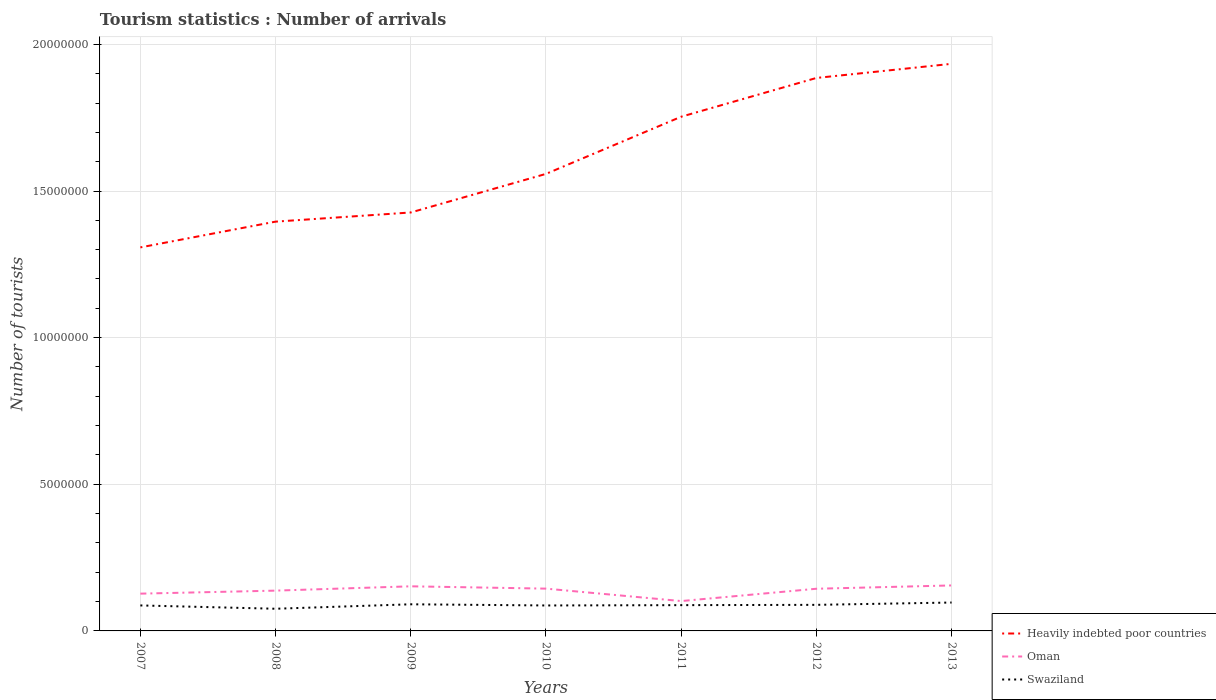How many different coloured lines are there?
Make the answer very short. 3. Across all years, what is the maximum number of tourist arrivals in Swaziland?
Ensure brevity in your answer.  7.56e+05. What is the total number of tourist arrivals in Swaziland in the graph?
Your answer should be compact. -8.90e+04. What is the difference between the highest and the second highest number of tourist arrivals in Oman?
Make the answer very short. 5.33e+05. What is the difference between the highest and the lowest number of tourist arrivals in Swaziland?
Offer a terse response. 4. Is the number of tourist arrivals in Swaziland strictly greater than the number of tourist arrivals in Oman over the years?
Give a very brief answer. Yes. What is the difference between two consecutive major ticks on the Y-axis?
Provide a succinct answer. 5.00e+06. Where does the legend appear in the graph?
Your answer should be compact. Bottom right. How are the legend labels stacked?
Provide a succinct answer. Vertical. What is the title of the graph?
Your response must be concise. Tourism statistics : Number of arrivals. Does "Vanuatu" appear as one of the legend labels in the graph?
Keep it short and to the point. No. What is the label or title of the X-axis?
Offer a terse response. Years. What is the label or title of the Y-axis?
Your answer should be very brief. Number of tourists. What is the Number of tourists of Heavily indebted poor countries in 2007?
Offer a terse response. 1.31e+07. What is the Number of tourists in Oman in 2007?
Give a very brief answer. 1.27e+06. What is the Number of tourists of Swaziland in 2007?
Provide a succinct answer. 8.69e+05. What is the Number of tourists of Heavily indebted poor countries in 2008?
Provide a short and direct response. 1.40e+07. What is the Number of tourists in Oman in 2008?
Your response must be concise. 1.37e+06. What is the Number of tourists in Swaziland in 2008?
Provide a succinct answer. 7.56e+05. What is the Number of tourists in Heavily indebted poor countries in 2009?
Ensure brevity in your answer.  1.43e+07. What is the Number of tourists in Oman in 2009?
Give a very brief answer. 1.52e+06. What is the Number of tourists of Swaziland in 2009?
Provide a succinct answer. 9.08e+05. What is the Number of tourists in Heavily indebted poor countries in 2010?
Offer a terse response. 1.56e+07. What is the Number of tourists in Oman in 2010?
Make the answer very short. 1.44e+06. What is the Number of tourists in Swaziland in 2010?
Provide a succinct answer. 8.68e+05. What is the Number of tourists of Heavily indebted poor countries in 2011?
Offer a terse response. 1.75e+07. What is the Number of tourists of Oman in 2011?
Your answer should be compact. 1.02e+06. What is the Number of tourists in Swaziland in 2011?
Offer a terse response. 8.79e+05. What is the Number of tourists in Heavily indebted poor countries in 2012?
Give a very brief answer. 1.89e+07. What is the Number of tourists of Oman in 2012?
Provide a succinct answer. 1.44e+06. What is the Number of tourists of Swaziland in 2012?
Provide a short and direct response. 8.89e+05. What is the Number of tourists in Heavily indebted poor countries in 2013?
Your answer should be compact. 1.93e+07. What is the Number of tourists in Oman in 2013?
Your answer should be compact. 1.55e+06. What is the Number of tourists in Swaziland in 2013?
Ensure brevity in your answer.  9.68e+05. Across all years, what is the maximum Number of tourists of Heavily indebted poor countries?
Your response must be concise. 1.93e+07. Across all years, what is the maximum Number of tourists of Oman?
Provide a short and direct response. 1.55e+06. Across all years, what is the maximum Number of tourists of Swaziland?
Provide a short and direct response. 9.68e+05. Across all years, what is the minimum Number of tourists in Heavily indebted poor countries?
Keep it short and to the point. 1.31e+07. Across all years, what is the minimum Number of tourists of Oman?
Make the answer very short. 1.02e+06. Across all years, what is the minimum Number of tourists in Swaziland?
Provide a short and direct response. 7.56e+05. What is the total Number of tourists of Heavily indebted poor countries in the graph?
Provide a succinct answer. 1.13e+08. What is the total Number of tourists of Oman in the graph?
Ensure brevity in your answer.  9.62e+06. What is the total Number of tourists of Swaziland in the graph?
Make the answer very short. 6.14e+06. What is the difference between the Number of tourists of Heavily indebted poor countries in 2007 and that in 2008?
Provide a succinct answer. -8.78e+05. What is the difference between the Number of tourists in Oman in 2007 and that in 2008?
Provide a succinct answer. -1.03e+05. What is the difference between the Number of tourists of Swaziland in 2007 and that in 2008?
Provide a short and direct response. 1.13e+05. What is the difference between the Number of tourists in Heavily indebted poor countries in 2007 and that in 2009?
Offer a very short reply. -1.19e+06. What is the difference between the Number of tourists in Swaziland in 2007 and that in 2009?
Make the answer very short. -3.90e+04. What is the difference between the Number of tourists in Heavily indebted poor countries in 2007 and that in 2010?
Keep it short and to the point. -2.51e+06. What is the difference between the Number of tourists in Oman in 2007 and that in 2010?
Provide a succinct answer. -1.71e+05. What is the difference between the Number of tourists of Swaziland in 2007 and that in 2010?
Offer a very short reply. 1000. What is the difference between the Number of tourists in Heavily indebted poor countries in 2007 and that in 2011?
Offer a very short reply. -4.46e+06. What is the difference between the Number of tourists in Oman in 2007 and that in 2011?
Give a very brief answer. 2.53e+05. What is the difference between the Number of tourists in Heavily indebted poor countries in 2007 and that in 2012?
Provide a short and direct response. -5.78e+06. What is the difference between the Number of tourists in Oman in 2007 and that in 2012?
Your answer should be compact. -1.67e+05. What is the difference between the Number of tourists of Swaziland in 2007 and that in 2012?
Offer a terse response. -2.00e+04. What is the difference between the Number of tourists of Heavily indebted poor countries in 2007 and that in 2013?
Make the answer very short. -6.26e+06. What is the difference between the Number of tourists of Oman in 2007 and that in 2013?
Provide a succinct answer. -2.80e+05. What is the difference between the Number of tourists of Swaziland in 2007 and that in 2013?
Ensure brevity in your answer.  -9.90e+04. What is the difference between the Number of tourists of Heavily indebted poor countries in 2008 and that in 2009?
Your answer should be very brief. -3.13e+05. What is the difference between the Number of tourists in Oman in 2008 and that in 2009?
Your answer should be very brief. -1.47e+05. What is the difference between the Number of tourists of Swaziland in 2008 and that in 2009?
Ensure brevity in your answer.  -1.52e+05. What is the difference between the Number of tourists in Heavily indebted poor countries in 2008 and that in 2010?
Make the answer very short. -1.63e+06. What is the difference between the Number of tourists in Oman in 2008 and that in 2010?
Keep it short and to the point. -6.80e+04. What is the difference between the Number of tourists in Swaziland in 2008 and that in 2010?
Your answer should be very brief. -1.12e+05. What is the difference between the Number of tourists in Heavily indebted poor countries in 2008 and that in 2011?
Give a very brief answer. -3.58e+06. What is the difference between the Number of tourists of Oman in 2008 and that in 2011?
Offer a very short reply. 3.56e+05. What is the difference between the Number of tourists of Swaziland in 2008 and that in 2011?
Provide a succinct answer. -1.23e+05. What is the difference between the Number of tourists in Heavily indebted poor countries in 2008 and that in 2012?
Your answer should be very brief. -4.90e+06. What is the difference between the Number of tourists in Oman in 2008 and that in 2012?
Make the answer very short. -6.40e+04. What is the difference between the Number of tourists in Swaziland in 2008 and that in 2012?
Provide a succinct answer. -1.33e+05. What is the difference between the Number of tourists of Heavily indebted poor countries in 2008 and that in 2013?
Keep it short and to the point. -5.38e+06. What is the difference between the Number of tourists in Oman in 2008 and that in 2013?
Offer a terse response. -1.77e+05. What is the difference between the Number of tourists of Swaziland in 2008 and that in 2013?
Your response must be concise. -2.12e+05. What is the difference between the Number of tourists of Heavily indebted poor countries in 2009 and that in 2010?
Ensure brevity in your answer.  -1.32e+06. What is the difference between the Number of tourists of Oman in 2009 and that in 2010?
Offer a very short reply. 7.90e+04. What is the difference between the Number of tourists in Heavily indebted poor countries in 2009 and that in 2011?
Offer a very short reply. -3.26e+06. What is the difference between the Number of tourists of Oman in 2009 and that in 2011?
Keep it short and to the point. 5.03e+05. What is the difference between the Number of tourists of Swaziland in 2009 and that in 2011?
Offer a very short reply. 2.90e+04. What is the difference between the Number of tourists in Heavily indebted poor countries in 2009 and that in 2012?
Offer a terse response. -4.59e+06. What is the difference between the Number of tourists in Oman in 2009 and that in 2012?
Your answer should be very brief. 8.30e+04. What is the difference between the Number of tourists in Swaziland in 2009 and that in 2012?
Ensure brevity in your answer.  1.90e+04. What is the difference between the Number of tourists in Heavily indebted poor countries in 2009 and that in 2013?
Your response must be concise. -5.07e+06. What is the difference between the Number of tourists in Oman in 2009 and that in 2013?
Provide a succinct answer. -3.00e+04. What is the difference between the Number of tourists in Swaziland in 2009 and that in 2013?
Your answer should be very brief. -6.00e+04. What is the difference between the Number of tourists in Heavily indebted poor countries in 2010 and that in 2011?
Make the answer very short. -1.95e+06. What is the difference between the Number of tourists in Oman in 2010 and that in 2011?
Your response must be concise. 4.24e+05. What is the difference between the Number of tourists of Swaziland in 2010 and that in 2011?
Give a very brief answer. -1.10e+04. What is the difference between the Number of tourists in Heavily indebted poor countries in 2010 and that in 2012?
Your answer should be very brief. -3.27e+06. What is the difference between the Number of tourists of Oman in 2010 and that in 2012?
Make the answer very short. 4000. What is the difference between the Number of tourists in Swaziland in 2010 and that in 2012?
Offer a terse response. -2.10e+04. What is the difference between the Number of tourists of Heavily indebted poor countries in 2010 and that in 2013?
Offer a terse response. -3.75e+06. What is the difference between the Number of tourists in Oman in 2010 and that in 2013?
Keep it short and to the point. -1.09e+05. What is the difference between the Number of tourists of Swaziland in 2010 and that in 2013?
Offer a terse response. -1.00e+05. What is the difference between the Number of tourists in Heavily indebted poor countries in 2011 and that in 2012?
Give a very brief answer. -1.32e+06. What is the difference between the Number of tourists of Oman in 2011 and that in 2012?
Your answer should be very brief. -4.20e+05. What is the difference between the Number of tourists of Swaziland in 2011 and that in 2012?
Offer a terse response. -10000. What is the difference between the Number of tourists of Heavily indebted poor countries in 2011 and that in 2013?
Keep it short and to the point. -1.80e+06. What is the difference between the Number of tourists in Oman in 2011 and that in 2013?
Ensure brevity in your answer.  -5.33e+05. What is the difference between the Number of tourists of Swaziland in 2011 and that in 2013?
Provide a succinct answer. -8.90e+04. What is the difference between the Number of tourists of Heavily indebted poor countries in 2012 and that in 2013?
Make the answer very short. -4.82e+05. What is the difference between the Number of tourists of Oman in 2012 and that in 2013?
Ensure brevity in your answer.  -1.13e+05. What is the difference between the Number of tourists of Swaziland in 2012 and that in 2013?
Ensure brevity in your answer.  -7.90e+04. What is the difference between the Number of tourists in Heavily indebted poor countries in 2007 and the Number of tourists in Oman in 2008?
Your response must be concise. 1.17e+07. What is the difference between the Number of tourists in Heavily indebted poor countries in 2007 and the Number of tourists in Swaziland in 2008?
Your answer should be compact. 1.23e+07. What is the difference between the Number of tourists of Oman in 2007 and the Number of tourists of Swaziland in 2008?
Your answer should be very brief. 5.15e+05. What is the difference between the Number of tourists in Heavily indebted poor countries in 2007 and the Number of tourists in Oman in 2009?
Your response must be concise. 1.16e+07. What is the difference between the Number of tourists in Heavily indebted poor countries in 2007 and the Number of tourists in Swaziland in 2009?
Ensure brevity in your answer.  1.22e+07. What is the difference between the Number of tourists of Oman in 2007 and the Number of tourists of Swaziland in 2009?
Offer a terse response. 3.63e+05. What is the difference between the Number of tourists of Heavily indebted poor countries in 2007 and the Number of tourists of Oman in 2010?
Provide a succinct answer. 1.16e+07. What is the difference between the Number of tourists in Heavily indebted poor countries in 2007 and the Number of tourists in Swaziland in 2010?
Your response must be concise. 1.22e+07. What is the difference between the Number of tourists in Oman in 2007 and the Number of tourists in Swaziland in 2010?
Make the answer very short. 4.03e+05. What is the difference between the Number of tourists in Heavily indebted poor countries in 2007 and the Number of tourists in Oman in 2011?
Keep it short and to the point. 1.21e+07. What is the difference between the Number of tourists in Heavily indebted poor countries in 2007 and the Number of tourists in Swaziland in 2011?
Give a very brief answer. 1.22e+07. What is the difference between the Number of tourists of Oman in 2007 and the Number of tourists of Swaziland in 2011?
Provide a succinct answer. 3.92e+05. What is the difference between the Number of tourists in Heavily indebted poor countries in 2007 and the Number of tourists in Oman in 2012?
Provide a short and direct response. 1.16e+07. What is the difference between the Number of tourists of Heavily indebted poor countries in 2007 and the Number of tourists of Swaziland in 2012?
Keep it short and to the point. 1.22e+07. What is the difference between the Number of tourists of Oman in 2007 and the Number of tourists of Swaziland in 2012?
Your answer should be very brief. 3.82e+05. What is the difference between the Number of tourists in Heavily indebted poor countries in 2007 and the Number of tourists in Oman in 2013?
Make the answer very short. 1.15e+07. What is the difference between the Number of tourists in Heavily indebted poor countries in 2007 and the Number of tourists in Swaziland in 2013?
Give a very brief answer. 1.21e+07. What is the difference between the Number of tourists in Oman in 2007 and the Number of tourists in Swaziland in 2013?
Your response must be concise. 3.03e+05. What is the difference between the Number of tourists in Heavily indebted poor countries in 2008 and the Number of tourists in Oman in 2009?
Your response must be concise. 1.24e+07. What is the difference between the Number of tourists in Heavily indebted poor countries in 2008 and the Number of tourists in Swaziland in 2009?
Give a very brief answer. 1.30e+07. What is the difference between the Number of tourists of Oman in 2008 and the Number of tourists of Swaziland in 2009?
Offer a very short reply. 4.66e+05. What is the difference between the Number of tourists in Heavily indebted poor countries in 2008 and the Number of tourists in Oman in 2010?
Ensure brevity in your answer.  1.25e+07. What is the difference between the Number of tourists of Heavily indebted poor countries in 2008 and the Number of tourists of Swaziland in 2010?
Your response must be concise. 1.31e+07. What is the difference between the Number of tourists of Oman in 2008 and the Number of tourists of Swaziland in 2010?
Keep it short and to the point. 5.06e+05. What is the difference between the Number of tourists in Heavily indebted poor countries in 2008 and the Number of tourists in Oman in 2011?
Your answer should be compact. 1.29e+07. What is the difference between the Number of tourists in Heavily indebted poor countries in 2008 and the Number of tourists in Swaziland in 2011?
Give a very brief answer. 1.31e+07. What is the difference between the Number of tourists of Oman in 2008 and the Number of tourists of Swaziland in 2011?
Make the answer very short. 4.95e+05. What is the difference between the Number of tourists in Heavily indebted poor countries in 2008 and the Number of tourists in Oman in 2012?
Your answer should be very brief. 1.25e+07. What is the difference between the Number of tourists in Heavily indebted poor countries in 2008 and the Number of tourists in Swaziland in 2012?
Offer a very short reply. 1.31e+07. What is the difference between the Number of tourists in Oman in 2008 and the Number of tourists in Swaziland in 2012?
Provide a succinct answer. 4.85e+05. What is the difference between the Number of tourists of Heavily indebted poor countries in 2008 and the Number of tourists of Oman in 2013?
Provide a short and direct response. 1.24e+07. What is the difference between the Number of tourists in Heavily indebted poor countries in 2008 and the Number of tourists in Swaziland in 2013?
Make the answer very short. 1.30e+07. What is the difference between the Number of tourists in Oman in 2008 and the Number of tourists in Swaziland in 2013?
Your response must be concise. 4.06e+05. What is the difference between the Number of tourists in Heavily indebted poor countries in 2009 and the Number of tourists in Oman in 2010?
Your answer should be compact. 1.28e+07. What is the difference between the Number of tourists of Heavily indebted poor countries in 2009 and the Number of tourists of Swaziland in 2010?
Your answer should be compact. 1.34e+07. What is the difference between the Number of tourists in Oman in 2009 and the Number of tourists in Swaziland in 2010?
Your response must be concise. 6.53e+05. What is the difference between the Number of tourists of Heavily indebted poor countries in 2009 and the Number of tourists of Oman in 2011?
Your answer should be very brief. 1.33e+07. What is the difference between the Number of tourists in Heavily indebted poor countries in 2009 and the Number of tourists in Swaziland in 2011?
Ensure brevity in your answer.  1.34e+07. What is the difference between the Number of tourists in Oman in 2009 and the Number of tourists in Swaziland in 2011?
Provide a short and direct response. 6.42e+05. What is the difference between the Number of tourists in Heavily indebted poor countries in 2009 and the Number of tourists in Oman in 2012?
Offer a very short reply. 1.28e+07. What is the difference between the Number of tourists of Heavily indebted poor countries in 2009 and the Number of tourists of Swaziland in 2012?
Make the answer very short. 1.34e+07. What is the difference between the Number of tourists in Oman in 2009 and the Number of tourists in Swaziland in 2012?
Provide a short and direct response. 6.32e+05. What is the difference between the Number of tourists in Heavily indebted poor countries in 2009 and the Number of tourists in Oman in 2013?
Your response must be concise. 1.27e+07. What is the difference between the Number of tourists of Heavily indebted poor countries in 2009 and the Number of tourists of Swaziland in 2013?
Keep it short and to the point. 1.33e+07. What is the difference between the Number of tourists of Oman in 2009 and the Number of tourists of Swaziland in 2013?
Ensure brevity in your answer.  5.53e+05. What is the difference between the Number of tourists of Heavily indebted poor countries in 2010 and the Number of tourists of Oman in 2011?
Provide a succinct answer. 1.46e+07. What is the difference between the Number of tourists in Heavily indebted poor countries in 2010 and the Number of tourists in Swaziland in 2011?
Ensure brevity in your answer.  1.47e+07. What is the difference between the Number of tourists in Oman in 2010 and the Number of tourists in Swaziland in 2011?
Offer a very short reply. 5.63e+05. What is the difference between the Number of tourists of Heavily indebted poor countries in 2010 and the Number of tourists of Oman in 2012?
Make the answer very short. 1.41e+07. What is the difference between the Number of tourists of Heavily indebted poor countries in 2010 and the Number of tourists of Swaziland in 2012?
Your answer should be very brief. 1.47e+07. What is the difference between the Number of tourists in Oman in 2010 and the Number of tourists in Swaziland in 2012?
Offer a very short reply. 5.53e+05. What is the difference between the Number of tourists of Heavily indebted poor countries in 2010 and the Number of tourists of Oman in 2013?
Your answer should be very brief. 1.40e+07. What is the difference between the Number of tourists of Heavily indebted poor countries in 2010 and the Number of tourists of Swaziland in 2013?
Offer a terse response. 1.46e+07. What is the difference between the Number of tourists of Oman in 2010 and the Number of tourists of Swaziland in 2013?
Provide a short and direct response. 4.74e+05. What is the difference between the Number of tourists in Heavily indebted poor countries in 2011 and the Number of tourists in Oman in 2012?
Offer a very short reply. 1.61e+07. What is the difference between the Number of tourists of Heavily indebted poor countries in 2011 and the Number of tourists of Swaziland in 2012?
Make the answer very short. 1.66e+07. What is the difference between the Number of tourists of Oman in 2011 and the Number of tourists of Swaziland in 2012?
Ensure brevity in your answer.  1.29e+05. What is the difference between the Number of tourists of Heavily indebted poor countries in 2011 and the Number of tourists of Oman in 2013?
Provide a short and direct response. 1.60e+07. What is the difference between the Number of tourists of Heavily indebted poor countries in 2011 and the Number of tourists of Swaziland in 2013?
Provide a succinct answer. 1.66e+07. What is the difference between the Number of tourists in Heavily indebted poor countries in 2012 and the Number of tourists in Oman in 2013?
Offer a very short reply. 1.73e+07. What is the difference between the Number of tourists of Heavily indebted poor countries in 2012 and the Number of tourists of Swaziland in 2013?
Provide a succinct answer. 1.79e+07. What is the difference between the Number of tourists in Oman in 2012 and the Number of tourists in Swaziland in 2013?
Offer a very short reply. 4.70e+05. What is the average Number of tourists of Heavily indebted poor countries per year?
Your answer should be very brief. 1.61e+07. What is the average Number of tourists of Oman per year?
Provide a short and direct response. 1.37e+06. What is the average Number of tourists in Swaziland per year?
Make the answer very short. 8.77e+05. In the year 2007, what is the difference between the Number of tourists in Heavily indebted poor countries and Number of tourists in Oman?
Give a very brief answer. 1.18e+07. In the year 2007, what is the difference between the Number of tourists of Heavily indebted poor countries and Number of tourists of Swaziland?
Your response must be concise. 1.22e+07. In the year 2007, what is the difference between the Number of tourists in Oman and Number of tourists in Swaziland?
Make the answer very short. 4.02e+05. In the year 2008, what is the difference between the Number of tourists in Heavily indebted poor countries and Number of tourists in Oman?
Your answer should be compact. 1.26e+07. In the year 2008, what is the difference between the Number of tourists in Heavily indebted poor countries and Number of tourists in Swaziland?
Keep it short and to the point. 1.32e+07. In the year 2008, what is the difference between the Number of tourists of Oman and Number of tourists of Swaziland?
Make the answer very short. 6.18e+05. In the year 2009, what is the difference between the Number of tourists of Heavily indebted poor countries and Number of tourists of Oman?
Keep it short and to the point. 1.27e+07. In the year 2009, what is the difference between the Number of tourists of Heavily indebted poor countries and Number of tourists of Swaziland?
Make the answer very short. 1.34e+07. In the year 2009, what is the difference between the Number of tourists of Oman and Number of tourists of Swaziland?
Provide a succinct answer. 6.13e+05. In the year 2010, what is the difference between the Number of tourists of Heavily indebted poor countries and Number of tourists of Oman?
Your answer should be compact. 1.41e+07. In the year 2010, what is the difference between the Number of tourists in Heavily indebted poor countries and Number of tourists in Swaziland?
Make the answer very short. 1.47e+07. In the year 2010, what is the difference between the Number of tourists in Oman and Number of tourists in Swaziland?
Provide a short and direct response. 5.74e+05. In the year 2011, what is the difference between the Number of tourists of Heavily indebted poor countries and Number of tourists of Oman?
Ensure brevity in your answer.  1.65e+07. In the year 2011, what is the difference between the Number of tourists of Heavily indebted poor countries and Number of tourists of Swaziland?
Your answer should be very brief. 1.67e+07. In the year 2011, what is the difference between the Number of tourists in Oman and Number of tourists in Swaziland?
Offer a terse response. 1.39e+05. In the year 2012, what is the difference between the Number of tourists of Heavily indebted poor countries and Number of tourists of Oman?
Provide a succinct answer. 1.74e+07. In the year 2012, what is the difference between the Number of tourists in Heavily indebted poor countries and Number of tourists in Swaziland?
Your response must be concise. 1.80e+07. In the year 2012, what is the difference between the Number of tourists of Oman and Number of tourists of Swaziland?
Give a very brief answer. 5.49e+05. In the year 2013, what is the difference between the Number of tourists in Heavily indebted poor countries and Number of tourists in Oman?
Your answer should be compact. 1.78e+07. In the year 2013, what is the difference between the Number of tourists of Heavily indebted poor countries and Number of tourists of Swaziland?
Your answer should be very brief. 1.84e+07. In the year 2013, what is the difference between the Number of tourists of Oman and Number of tourists of Swaziland?
Your response must be concise. 5.83e+05. What is the ratio of the Number of tourists of Heavily indebted poor countries in 2007 to that in 2008?
Your answer should be compact. 0.94. What is the ratio of the Number of tourists in Oman in 2007 to that in 2008?
Your answer should be compact. 0.93. What is the ratio of the Number of tourists of Swaziland in 2007 to that in 2008?
Your answer should be very brief. 1.15. What is the ratio of the Number of tourists in Heavily indebted poor countries in 2007 to that in 2009?
Ensure brevity in your answer.  0.92. What is the ratio of the Number of tourists of Oman in 2007 to that in 2009?
Offer a terse response. 0.84. What is the ratio of the Number of tourists in Heavily indebted poor countries in 2007 to that in 2010?
Your response must be concise. 0.84. What is the ratio of the Number of tourists of Oman in 2007 to that in 2010?
Provide a succinct answer. 0.88. What is the ratio of the Number of tourists of Heavily indebted poor countries in 2007 to that in 2011?
Ensure brevity in your answer.  0.75. What is the ratio of the Number of tourists in Oman in 2007 to that in 2011?
Your response must be concise. 1.25. What is the ratio of the Number of tourists in Swaziland in 2007 to that in 2011?
Make the answer very short. 0.99. What is the ratio of the Number of tourists of Heavily indebted poor countries in 2007 to that in 2012?
Provide a succinct answer. 0.69. What is the ratio of the Number of tourists in Oman in 2007 to that in 2012?
Ensure brevity in your answer.  0.88. What is the ratio of the Number of tourists of Swaziland in 2007 to that in 2012?
Keep it short and to the point. 0.98. What is the ratio of the Number of tourists of Heavily indebted poor countries in 2007 to that in 2013?
Give a very brief answer. 0.68. What is the ratio of the Number of tourists of Oman in 2007 to that in 2013?
Keep it short and to the point. 0.82. What is the ratio of the Number of tourists of Swaziland in 2007 to that in 2013?
Provide a short and direct response. 0.9. What is the ratio of the Number of tourists in Heavily indebted poor countries in 2008 to that in 2009?
Your answer should be very brief. 0.98. What is the ratio of the Number of tourists of Oman in 2008 to that in 2009?
Ensure brevity in your answer.  0.9. What is the ratio of the Number of tourists of Swaziland in 2008 to that in 2009?
Offer a very short reply. 0.83. What is the ratio of the Number of tourists of Heavily indebted poor countries in 2008 to that in 2010?
Provide a short and direct response. 0.9. What is the ratio of the Number of tourists of Oman in 2008 to that in 2010?
Offer a very short reply. 0.95. What is the ratio of the Number of tourists in Swaziland in 2008 to that in 2010?
Your answer should be very brief. 0.87. What is the ratio of the Number of tourists of Heavily indebted poor countries in 2008 to that in 2011?
Provide a succinct answer. 0.8. What is the ratio of the Number of tourists of Oman in 2008 to that in 2011?
Provide a short and direct response. 1.35. What is the ratio of the Number of tourists in Swaziland in 2008 to that in 2011?
Give a very brief answer. 0.86. What is the ratio of the Number of tourists of Heavily indebted poor countries in 2008 to that in 2012?
Give a very brief answer. 0.74. What is the ratio of the Number of tourists of Oman in 2008 to that in 2012?
Ensure brevity in your answer.  0.96. What is the ratio of the Number of tourists in Swaziland in 2008 to that in 2012?
Provide a succinct answer. 0.85. What is the ratio of the Number of tourists in Heavily indebted poor countries in 2008 to that in 2013?
Ensure brevity in your answer.  0.72. What is the ratio of the Number of tourists in Oman in 2008 to that in 2013?
Your response must be concise. 0.89. What is the ratio of the Number of tourists of Swaziland in 2008 to that in 2013?
Make the answer very short. 0.78. What is the ratio of the Number of tourists of Heavily indebted poor countries in 2009 to that in 2010?
Provide a short and direct response. 0.92. What is the ratio of the Number of tourists of Oman in 2009 to that in 2010?
Your answer should be very brief. 1.05. What is the ratio of the Number of tourists of Swaziland in 2009 to that in 2010?
Offer a terse response. 1.05. What is the ratio of the Number of tourists in Heavily indebted poor countries in 2009 to that in 2011?
Provide a short and direct response. 0.81. What is the ratio of the Number of tourists of Oman in 2009 to that in 2011?
Your answer should be compact. 1.49. What is the ratio of the Number of tourists of Swaziland in 2009 to that in 2011?
Give a very brief answer. 1.03. What is the ratio of the Number of tourists of Heavily indebted poor countries in 2009 to that in 2012?
Keep it short and to the point. 0.76. What is the ratio of the Number of tourists of Oman in 2009 to that in 2012?
Your answer should be compact. 1.06. What is the ratio of the Number of tourists of Swaziland in 2009 to that in 2012?
Provide a short and direct response. 1.02. What is the ratio of the Number of tourists in Heavily indebted poor countries in 2009 to that in 2013?
Your answer should be very brief. 0.74. What is the ratio of the Number of tourists of Oman in 2009 to that in 2013?
Provide a short and direct response. 0.98. What is the ratio of the Number of tourists in Swaziland in 2009 to that in 2013?
Offer a terse response. 0.94. What is the ratio of the Number of tourists of Heavily indebted poor countries in 2010 to that in 2011?
Make the answer very short. 0.89. What is the ratio of the Number of tourists in Oman in 2010 to that in 2011?
Give a very brief answer. 1.42. What is the ratio of the Number of tourists in Swaziland in 2010 to that in 2011?
Make the answer very short. 0.99. What is the ratio of the Number of tourists in Heavily indebted poor countries in 2010 to that in 2012?
Your answer should be very brief. 0.83. What is the ratio of the Number of tourists in Swaziland in 2010 to that in 2012?
Your answer should be compact. 0.98. What is the ratio of the Number of tourists in Heavily indebted poor countries in 2010 to that in 2013?
Provide a succinct answer. 0.81. What is the ratio of the Number of tourists in Oman in 2010 to that in 2013?
Your response must be concise. 0.93. What is the ratio of the Number of tourists in Swaziland in 2010 to that in 2013?
Offer a terse response. 0.9. What is the ratio of the Number of tourists of Heavily indebted poor countries in 2011 to that in 2012?
Ensure brevity in your answer.  0.93. What is the ratio of the Number of tourists in Oman in 2011 to that in 2012?
Provide a succinct answer. 0.71. What is the ratio of the Number of tourists in Heavily indebted poor countries in 2011 to that in 2013?
Your answer should be very brief. 0.91. What is the ratio of the Number of tourists of Oman in 2011 to that in 2013?
Offer a terse response. 0.66. What is the ratio of the Number of tourists in Swaziland in 2011 to that in 2013?
Your answer should be very brief. 0.91. What is the ratio of the Number of tourists of Heavily indebted poor countries in 2012 to that in 2013?
Offer a terse response. 0.98. What is the ratio of the Number of tourists of Oman in 2012 to that in 2013?
Ensure brevity in your answer.  0.93. What is the ratio of the Number of tourists in Swaziland in 2012 to that in 2013?
Offer a very short reply. 0.92. What is the difference between the highest and the second highest Number of tourists of Heavily indebted poor countries?
Provide a succinct answer. 4.82e+05. What is the difference between the highest and the lowest Number of tourists of Heavily indebted poor countries?
Offer a very short reply. 6.26e+06. What is the difference between the highest and the lowest Number of tourists of Oman?
Give a very brief answer. 5.33e+05. What is the difference between the highest and the lowest Number of tourists of Swaziland?
Keep it short and to the point. 2.12e+05. 